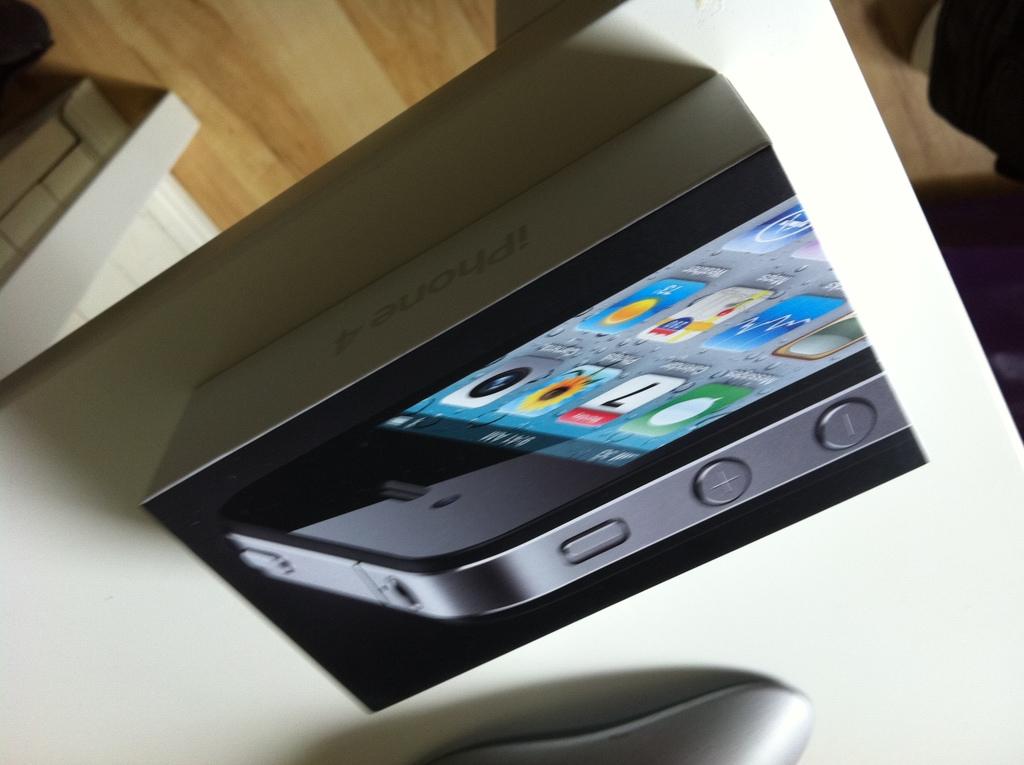What kind of phone is this?
Give a very brief answer. Iphone. 